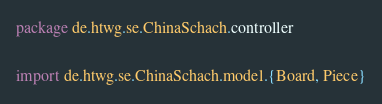<code> <loc_0><loc_0><loc_500><loc_500><_Scala_>package de.htwg.se.ChinaSchach.controller

import de.htwg.se.ChinaSchach.model.{Board, Piece}</code> 